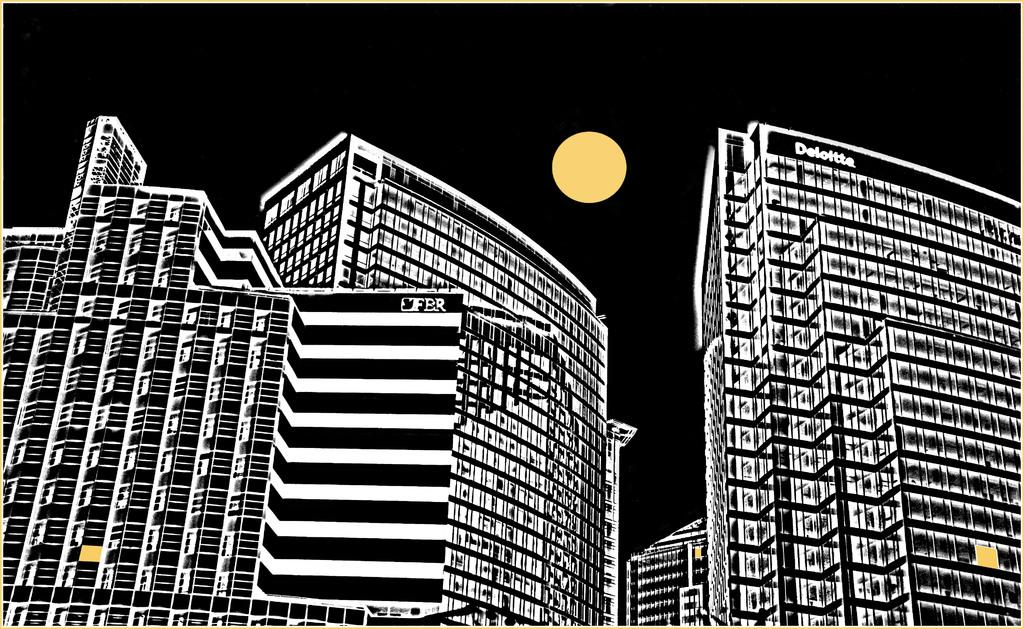What type of structures are depicted in the image? The image contains edited buildings. Are there any words or phrases on the image? Yes, there is text on the image. What celestial body can be seen in the image? The moon is visible in the image. How many cattle are grazing in the image? There are no cattle present in the image. 